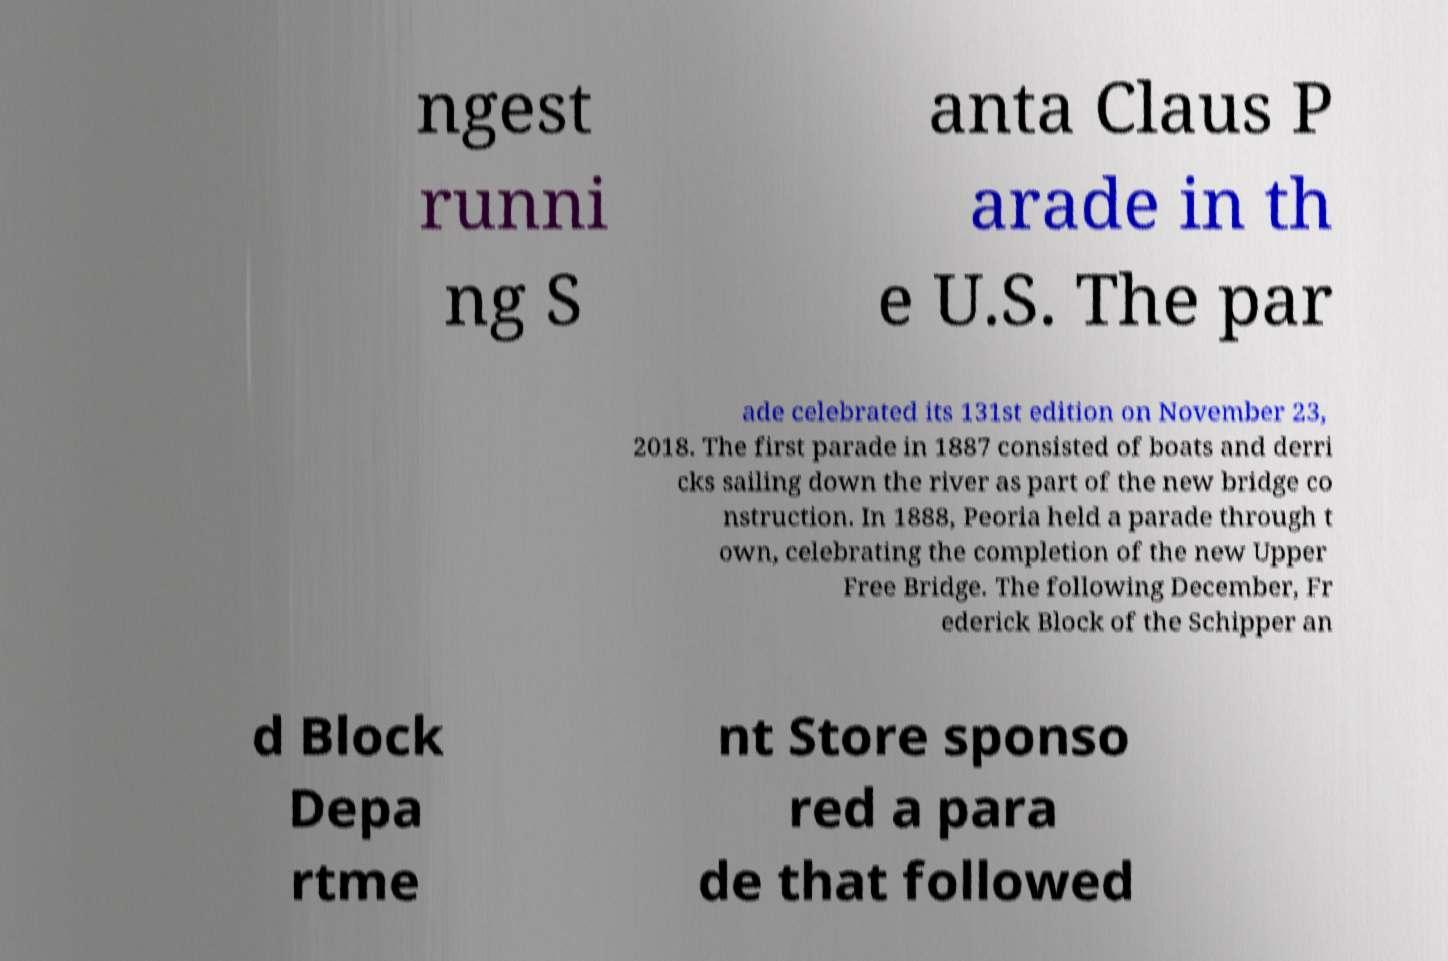What messages or text are displayed in this image? I need them in a readable, typed format. ngest runni ng S anta Claus P arade in th e U.S. The par ade celebrated its 131st edition on November 23, 2018. The first parade in 1887 consisted of boats and derri cks sailing down the river as part of the new bridge co nstruction. In 1888, Peoria held a parade through t own, celebrating the completion of the new Upper Free Bridge. The following December, Fr ederick Block of the Schipper an d Block Depa rtme nt Store sponso red a para de that followed 